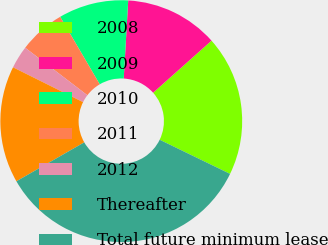<chart> <loc_0><loc_0><loc_500><loc_500><pie_chart><fcel>2008<fcel>2009<fcel>2010<fcel>2011<fcel>2012<fcel>Thereafter<fcel>Total future minimum lease<nl><fcel>18.78%<fcel>12.49%<fcel>9.34%<fcel>6.19%<fcel>3.04%<fcel>15.63%<fcel>34.52%<nl></chart> 